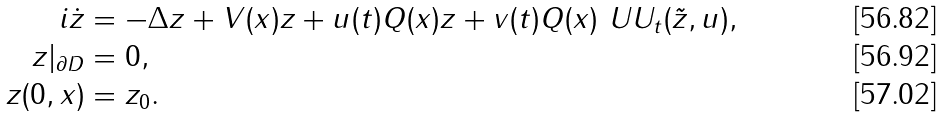Convert formula to latex. <formula><loc_0><loc_0><loc_500><loc_500>i \dot { z } & = - \Delta z + V ( x ) z + u ( t ) Q ( x ) z + v ( t ) Q ( x ) \ U U _ { t } ( \tilde { z } , u ) , \, \\ z | _ { \partial D } & = 0 , \\ z ( 0 , x ) & = z _ { 0 } .</formula> 